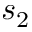<formula> <loc_0><loc_0><loc_500><loc_500>s _ { 2 }</formula> 